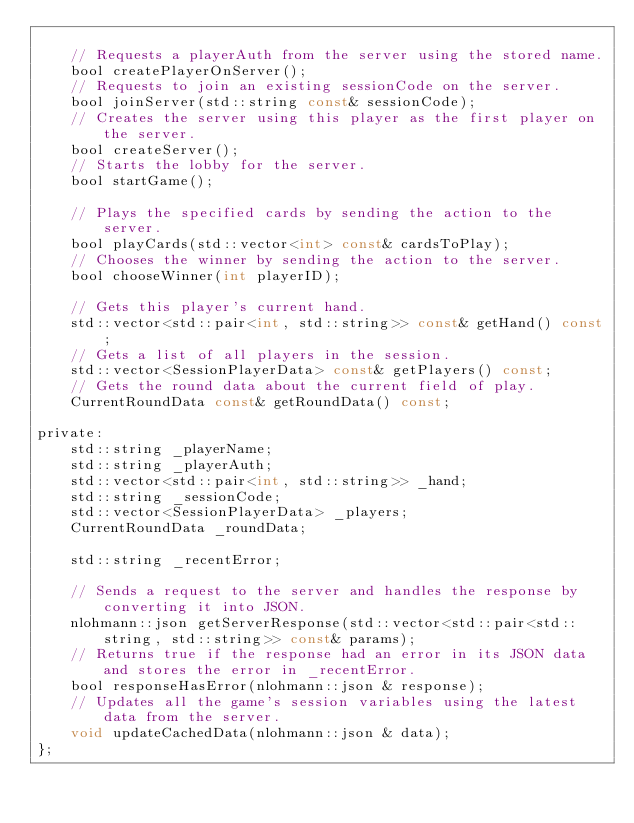Convert code to text. <code><loc_0><loc_0><loc_500><loc_500><_C_>
	// Requests a playerAuth from the server using the stored name.
	bool createPlayerOnServer();
	// Requests to join an existing sessionCode on the server.
	bool joinServer(std::string const& sessionCode);
	// Creates the server using this player as the first player on the server.
	bool createServer();
	// Starts the lobby for the server.
	bool startGame();

	// Plays the specified cards by sending the action to the server.
	bool playCards(std::vector<int> const& cardsToPlay);
	// Chooses the winner by sending the action to the server.
	bool chooseWinner(int playerID);

	// Gets this player's current hand.
	std::vector<std::pair<int, std::string>> const& getHand() const;
	// Gets a list of all players in the session.
	std::vector<SessionPlayerData> const& getPlayers() const;
	// Gets the round data about the current field of play.
	CurrentRoundData const& getRoundData() const;

private:
	std::string _playerName;
	std::string _playerAuth;
	std::vector<std::pair<int, std::string>> _hand;
	std::string _sessionCode;
	std::vector<SessionPlayerData> _players;
	CurrentRoundData _roundData;

	std::string _recentError;

	// Sends a request to the server and handles the response by converting it into JSON.
	nlohmann::json getServerResponse(std::vector<std::pair<std::string, std::string>> const& params);
	// Returns true if the response had an error in its JSON data and stores the error in _recentError.
	bool responseHasError(nlohmann::json & response);
	// Updates all the game's session variables using the latest data from the server.
	void updateCachedData(nlohmann::json & data);
};

</code> 